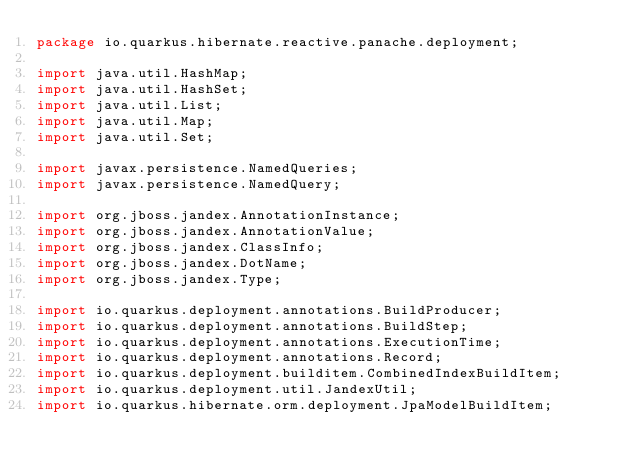<code> <loc_0><loc_0><loc_500><loc_500><_Java_>package io.quarkus.hibernate.reactive.panache.deployment;

import java.util.HashMap;
import java.util.HashSet;
import java.util.List;
import java.util.Map;
import java.util.Set;

import javax.persistence.NamedQueries;
import javax.persistence.NamedQuery;

import org.jboss.jandex.AnnotationInstance;
import org.jboss.jandex.AnnotationValue;
import org.jboss.jandex.ClassInfo;
import org.jboss.jandex.DotName;
import org.jboss.jandex.Type;

import io.quarkus.deployment.annotations.BuildProducer;
import io.quarkus.deployment.annotations.BuildStep;
import io.quarkus.deployment.annotations.ExecutionTime;
import io.quarkus.deployment.annotations.Record;
import io.quarkus.deployment.builditem.CombinedIndexBuildItem;
import io.quarkus.deployment.util.JandexUtil;
import io.quarkus.hibernate.orm.deployment.JpaModelBuildItem;</code> 